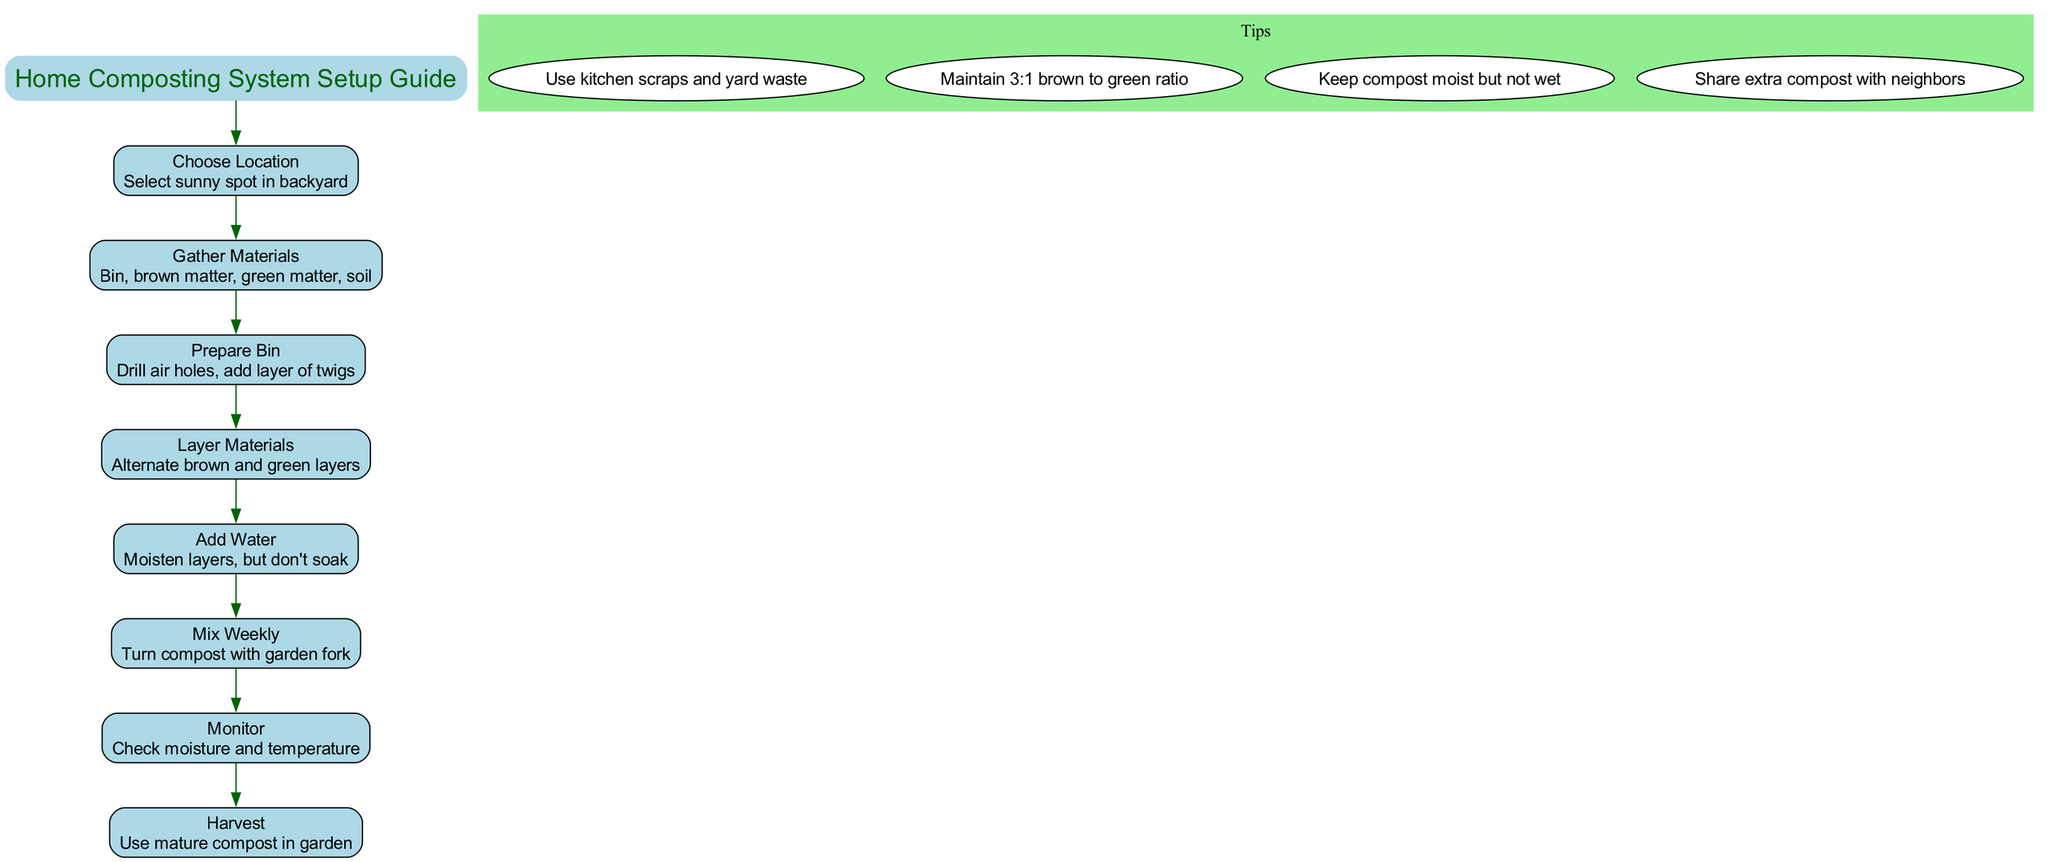What is the first step in setting up a composting system? The first step listed in the diagram is "Choose Location." It is shown as the initial node after the title.
Answer: Choose Location How many main steps are there in the composting setup? Counting all nodes labeled as steps in the diagram reveals there are eight steps total.
Answer: Eight What type of materials should be gathered for composting? The diagram states the materials to gather include "Bin, brown matter, green matter, soil," which are all listed in the second step.
Answer: Bin, brown matter, green matter, soil What is the recommended moisture level for the compost? The tips section advises to "Keep compost moist but not wet," indicating the desired moisture condition.
Answer: Moist but not wet Which step involves mixing the compost? The step labeled "Mix Weekly" includes the action of turning the compost with a garden fork, indicating the mixing process.
Answer: Mix Weekly How should the layers be arranged in the compost bin? The diagram describes to "Alternate brown and green layers," indicating the proper layering technique for compost materials.
Answer: Alternate brown and green layers What is the last step in the composting process? The final step displayed in the flow of the diagram is "Harvest," which signifies when the compost is ready to be used in the garden.
Answer: Harvest How is suggested to use excess compost? The tip states to "Share extra compost with neighbors," indicating a community-sharing practice for surplus compost.
Answer: Share extra compost with neighbors What shape is used for the tips in the diagram? The diagram indicates that the tips are displayed within an ellipse shape, which is a unique characteristic for tips.
Answer: Ellipse 